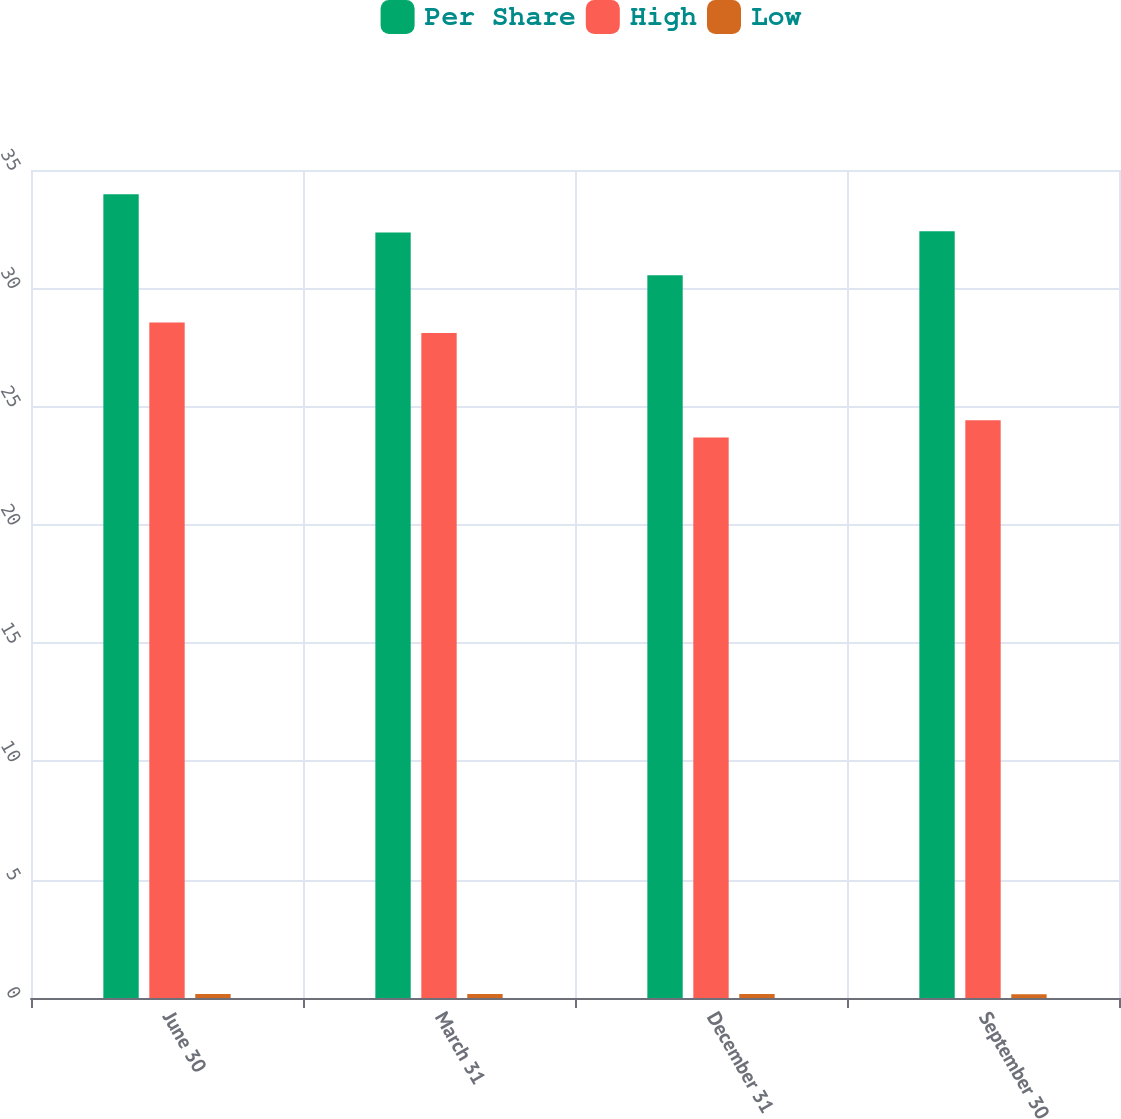Convert chart. <chart><loc_0><loc_0><loc_500><loc_500><stacked_bar_chart><ecel><fcel>June 30<fcel>March 31<fcel>December 31<fcel>September 30<nl><fcel>Per Share<fcel>33.98<fcel>32.36<fcel>30.55<fcel>32.41<nl><fcel>High<fcel>28.55<fcel>28.11<fcel>23.69<fcel>24.42<nl><fcel>Low<fcel>0.17<fcel>0.17<fcel>0.17<fcel>0.16<nl></chart> 